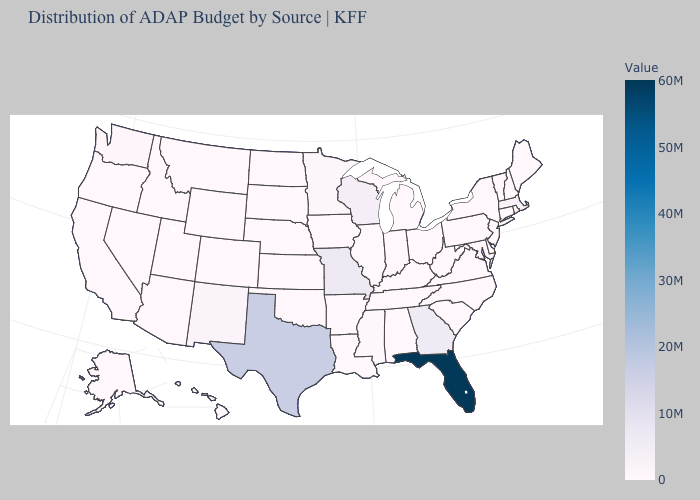Does Minnesota have the highest value in the MidWest?
Quick response, please. No. Is the legend a continuous bar?
Be succinct. Yes. 